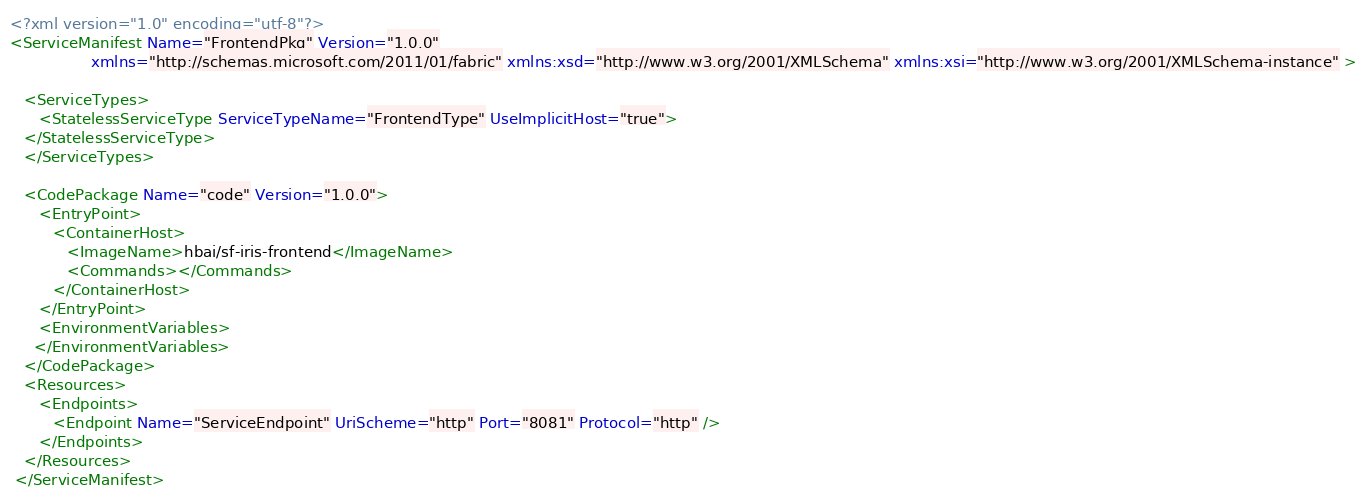<code> <loc_0><loc_0><loc_500><loc_500><_XML_><?xml version="1.0" encoding="utf-8"?>
<ServiceManifest Name="FrontendPkg" Version="1.0.0"
                 xmlns="http://schemas.microsoft.com/2011/01/fabric" xmlns:xsd="http://www.w3.org/2001/XMLSchema" xmlns:xsi="http://www.w3.org/2001/XMLSchema-instance" >

   <ServiceTypes>
      <StatelessServiceType ServiceTypeName="FrontendType" UseImplicitHost="true">
   </StatelessServiceType>
   </ServiceTypes>
   
   <CodePackage Name="code" Version="1.0.0">
      <EntryPoint>
         <ContainerHost>
            <ImageName>hbai/sf-iris-frontend</ImageName>
            <Commands></Commands>
         </ContainerHost>
      </EntryPoint>
      <EnvironmentVariables> 
	 </EnvironmentVariables> 
   </CodePackage>
   <Resources>
      <Endpoints>
         <Endpoint Name="ServiceEndpoint" UriScheme="http" Port="8081" Protocol="http" />
      </Endpoints>
   </Resources>
 </ServiceManifest>
</code> 